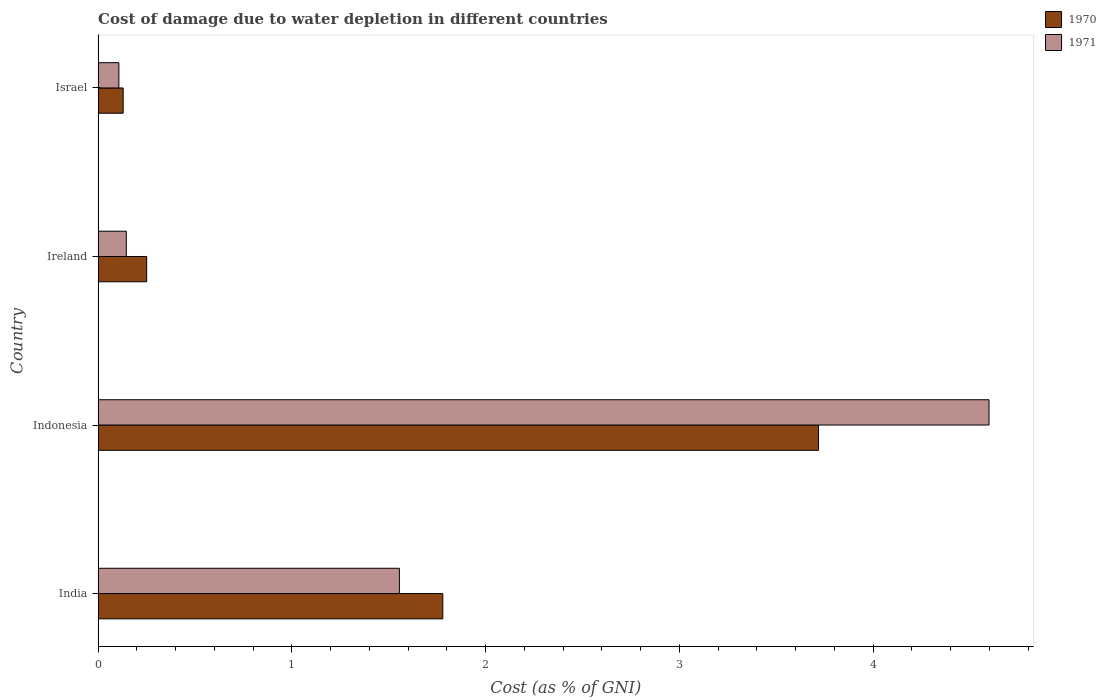How many different coloured bars are there?
Offer a very short reply. 2. Are the number of bars on each tick of the Y-axis equal?
Ensure brevity in your answer.  Yes. How many bars are there on the 4th tick from the top?
Keep it short and to the point. 2. How many bars are there on the 1st tick from the bottom?
Ensure brevity in your answer.  2. What is the label of the 4th group of bars from the top?
Your answer should be compact. India. In how many cases, is the number of bars for a given country not equal to the number of legend labels?
Provide a short and direct response. 0. What is the cost of damage caused due to water depletion in 1971 in Ireland?
Your response must be concise. 0.15. Across all countries, what is the maximum cost of damage caused due to water depletion in 1971?
Give a very brief answer. 4.6. Across all countries, what is the minimum cost of damage caused due to water depletion in 1970?
Give a very brief answer. 0.13. In which country was the cost of damage caused due to water depletion in 1970 minimum?
Make the answer very short. Israel. What is the total cost of damage caused due to water depletion in 1970 in the graph?
Give a very brief answer. 5.88. What is the difference between the cost of damage caused due to water depletion in 1970 in India and that in Indonesia?
Give a very brief answer. -1.94. What is the difference between the cost of damage caused due to water depletion in 1970 in Indonesia and the cost of damage caused due to water depletion in 1971 in Israel?
Provide a succinct answer. 3.61. What is the average cost of damage caused due to water depletion in 1970 per country?
Your answer should be very brief. 1.47. What is the difference between the cost of damage caused due to water depletion in 1971 and cost of damage caused due to water depletion in 1970 in Ireland?
Keep it short and to the point. -0.11. In how many countries, is the cost of damage caused due to water depletion in 1970 greater than 1 %?
Give a very brief answer. 2. What is the ratio of the cost of damage caused due to water depletion in 1971 in Indonesia to that in Israel?
Provide a short and direct response. 42.92. Is the cost of damage caused due to water depletion in 1970 in India less than that in Ireland?
Keep it short and to the point. No. Is the difference between the cost of damage caused due to water depletion in 1971 in India and Israel greater than the difference between the cost of damage caused due to water depletion in 1970 in India and Israel?
Give a very brief answer. No. What is the difference between the highest and the second highest cost of damage caused due to water depletion in 1970?
Your response must be concise. 1.94. What is the difference between the highest and the lowest cost of damage caused due to water depletion in 1970?
Offer a very short reply. 3.59. Is the sum of the cost of damage caused due to water depletion in 1971 in India and Ireland greater than the maximum cost of damage caused due to water depletion in 1970 across all countries?
Your answer should be compact. No. What does the 1st bar from the top in Israel represents?
Keep it short and to the point. 1971. How many countries are there in the graph?
Give a very brief answer. 4. What is the difference between two consecutive major ticks on the X-axis?
Your answer should be compact. 1. Are the values on the major ticks of X-axis written in scientific E-notation?
Provide a succinct answer. No. Does the graph contain any zero values?
Keep it short and to the point. No. Where does the legend appear in the graph?
Provide a short and direct response. Top right. How many legend labels are there?
Give a very brief answer. 2. How are the legend labels stacked?
Offer a terse response. Vertical. What is the title of the graph?
Offer a terse response. Cost of damage due to water depletion in different countries. Does "1975" appear as one of the legend labels in the graph?
Your answer should be very brief. No. What is the label or title of the X-axis?
Provide a succinct answer. Cost (as % of GNI). What is the label or title of the Y-axis?
Your response must be concise. Country. What is the Cost (as % of GNI) in 1970 in India?
Provide a short and direct response. 1.78. What is the Cost (as % of GNI) of 1971 in India?
Ensure brevity in your answer.  1.55. What is the Cost (as % of GNI) in 1970 in Indonesia?
Make the answer very short. 3.72. What is the Cost (as % of GNI) in 1971 in Indonesia?
Give a very brief answer. 4.6. What is the Cost (as % of GNI) in 1970 in Ireland?
Offer a very short reply. 0.25. What is the Cost (as % of GNI) of 1971 in Ireland?
Give a very brief answer. 0.15. What is the Cost (as % of GNI) of 1970 in Israel?
Your answer should be compact. 0.13. What is the Cost (as % of GNI) in 1971 in Israel?
Your answer should be very brief. 0.11. Across all countries, what is the maximum Cost (as % of GNI) in 1970?
Make the answer very short. 3.72. Across all countries, what is the maximum Cost (as % of GNI) of 1971?
Your response must be concise. 4.6. Across all countries, what is the minimum Cost (as % of GNI) of 1970?
Keep it short and to the point. 0.13. Across all countries, what is the minimum Cost (as % of GNI) in 1971?
Give a very brief answer. 0.11. What is the total Cost (as % of GNI) in 1970 in the graph?
Your answer should be very brief. 5.88. What is the total Cost (as % of GNI) of 1971 in the graph?
Offer a terse response. 6.41. What is the difference between the Cost (as % of GNI) in 1970 in India and that in Indonesia?
Provide a succinct answer. -1.94. What is the difference between the Cost (as % of GNI) in 1971 in India and that in Indonesia?
Ensure brevity in your answer.  -3.04. What is the difference between the Cost (as % of GNI) in 1970 in India and that in Ireland?
Give a very brief answer. 1.53. What is the difference between the Cost (as % of GNI) of 1971 in India and that in Ireland?
Make the answer very short. 1.41. What is the difference between the Cost (as % of GNI) in 1970 in India and that in Israel?
Offer a terse response. 1.65. What is the difference between the Cost (as % of GNI) of 1971 in India and that in Israel?
Provide a short and direct response. 1.45. What is the difference between the Cost (as % of GNI) in 1970 in Indonesia and that in Ireland?
Offer a terse response. 3.47. What is the difference between the Cost (as % of GNI) of 1971 in Indonesia and that in Ireland?
Provide a short and direct response. 4.45. What is the difference between the Cost (as % of GNI) in 1970 in Indonesia and that in Israel?
Your answer should be compact. 3.59. What is the difference between the Cost (as % of GNI) of 1971 in Indonesia and that in Israel?
Provide a short and direct response. 4.49. What is the difference between the Cost (as % of GNI) in 1970 in Ireland and that in Israel?
Ensure brevity in your answer.  0.12. What is the difference between the Cost (as % of GNI) of 1971 in Ireland and that in Israel?
Your response must be concise. 0.04. What is the difference between the Cost (as % of GNI) in 1970 in India and the Cost (as % of GNI) in 1971 in Indonesia?
Provide a succinct answer. -2.82. What is the difference between the Cost (as % of GNI) in 1970 in India and the Cost (as % of GNI) in 1971 in Ireland?
Ensure brevity in your answer.  1.63. What is the difference between the Cost (as % of GNI) of 1970 in India and the Cost (as % of GNI) of 1971 in Israel?
Offer a very short reply. 1.67. What is the difference between the Cost (as % of GNI) in 1970 in Indonesia and the Cost (as % of GNI) in 1971 in Ireland?
Offer a very short reply. 3.57. What is the difference between the Cost (as % of GNI) of 1970 in Indonesia and the Cost (as % of GNI) of 1971 in Israel?
Your response must be concise. 3.61. What is the difference between the Cost (as % of GNI) of 1970 in Ireland and the Cost (as % of GNI) of 1971 in Israel?
Ensure brevity in your answer.  0.14. What is the average Cost (as % of GNI) in 1970 per country?
Your answer should be very brief. 1.47. What is the average Cost (as % of GNI) of 1971 per country?
Offer a terse response. 1.6. What is the difference between the Cost (as % of GNI) of 1970 and Cost (as % of GNI) of 1971 in India?
Keep it short and to the point. 0.22. What is the difference between the Cost (as % of GNI) in 1970 and Cost (as % of GNI) in 1971 in Indonesia?
Provide a short and direct response. -0.88. What is the difference between the Cost (as % of GNI) in 1970 and Cost (as % of GNI) in 1971 in Ireland?
Offer a terse response. 0.1. What is the difference between the Cost (as % of GNI) of 1970 and Cost (as % of GNI) of 1971 in Israel?
Make the answer very short. 0.02. What is the ratio of the Cost (as % of GNI) of 1970 in India to that in Indonesia?
Your answer should be compact. 0.48. What is the ratio of the Cost (as % of GNI) of 1971 in India to that in Indonesia?
Your answer should be very brief. 0.34. What is the ratio of the Cost (as % of GNI) in 1970 in India to that in Ireland?
Your answer should be compact. 7.1. What is the ratio of the Cost (as % of GNI) in 1971 in India to that in Ireland?
Your response must be concise. 10.68. What is the ratio of the Cost (as % of GNI) in 1970 in India to that in Israel?
Provide a succinct answer. 13.76. What is the ratio of the Cost (as % of GNI) in 1971 in India to that in Israel?
Give a very brief answer. 14.51. What is the ratio of the Cost (as % of GNI) in 1970 in Indonesia to that in Ireland?
Ensure brevity in your answer.  14.83. What is the ratio of the Cost (as % of GNI) of 1971 in Indonesia to that in Ireland?
Ensure brevity in your answer.  31.57. What is the ratio of the Cost (as % of GNI) in 1970 in Indonesia to that in Israel?
Give a very brief answer. 28.75. What is the ratio of the Cost (as % of GNI) in 1971 in Indonesia to that in Israel?
Offer a very short reply. 42.92. What is the ratio of the Cost (as % of GNI) of 1970 in Ireland to that in Israel?
Provide a succinct answer. 1.94. What is the ratio of the Cost (as % of GNI) of 1971 in Ireland to that in Israel?
Keep it short and to the point. 1.36. What is the difference between the highest and the second highest Cost (as % of GNI) of 1970?
Keep it short and to the point. 1.94. What is the difference between the highest and the second highest Cost (as % of GNI) of 1971?
Offer a terse response. 3.04. What is the difference between the highest and the lowest Cost (as % of GNI) of 1970?
Offer a very short reply. 3.59. What is the difference between the highest and the lowest Cost (as % of GNI) of 1971?
Your answer should be very brief. 4.49. 